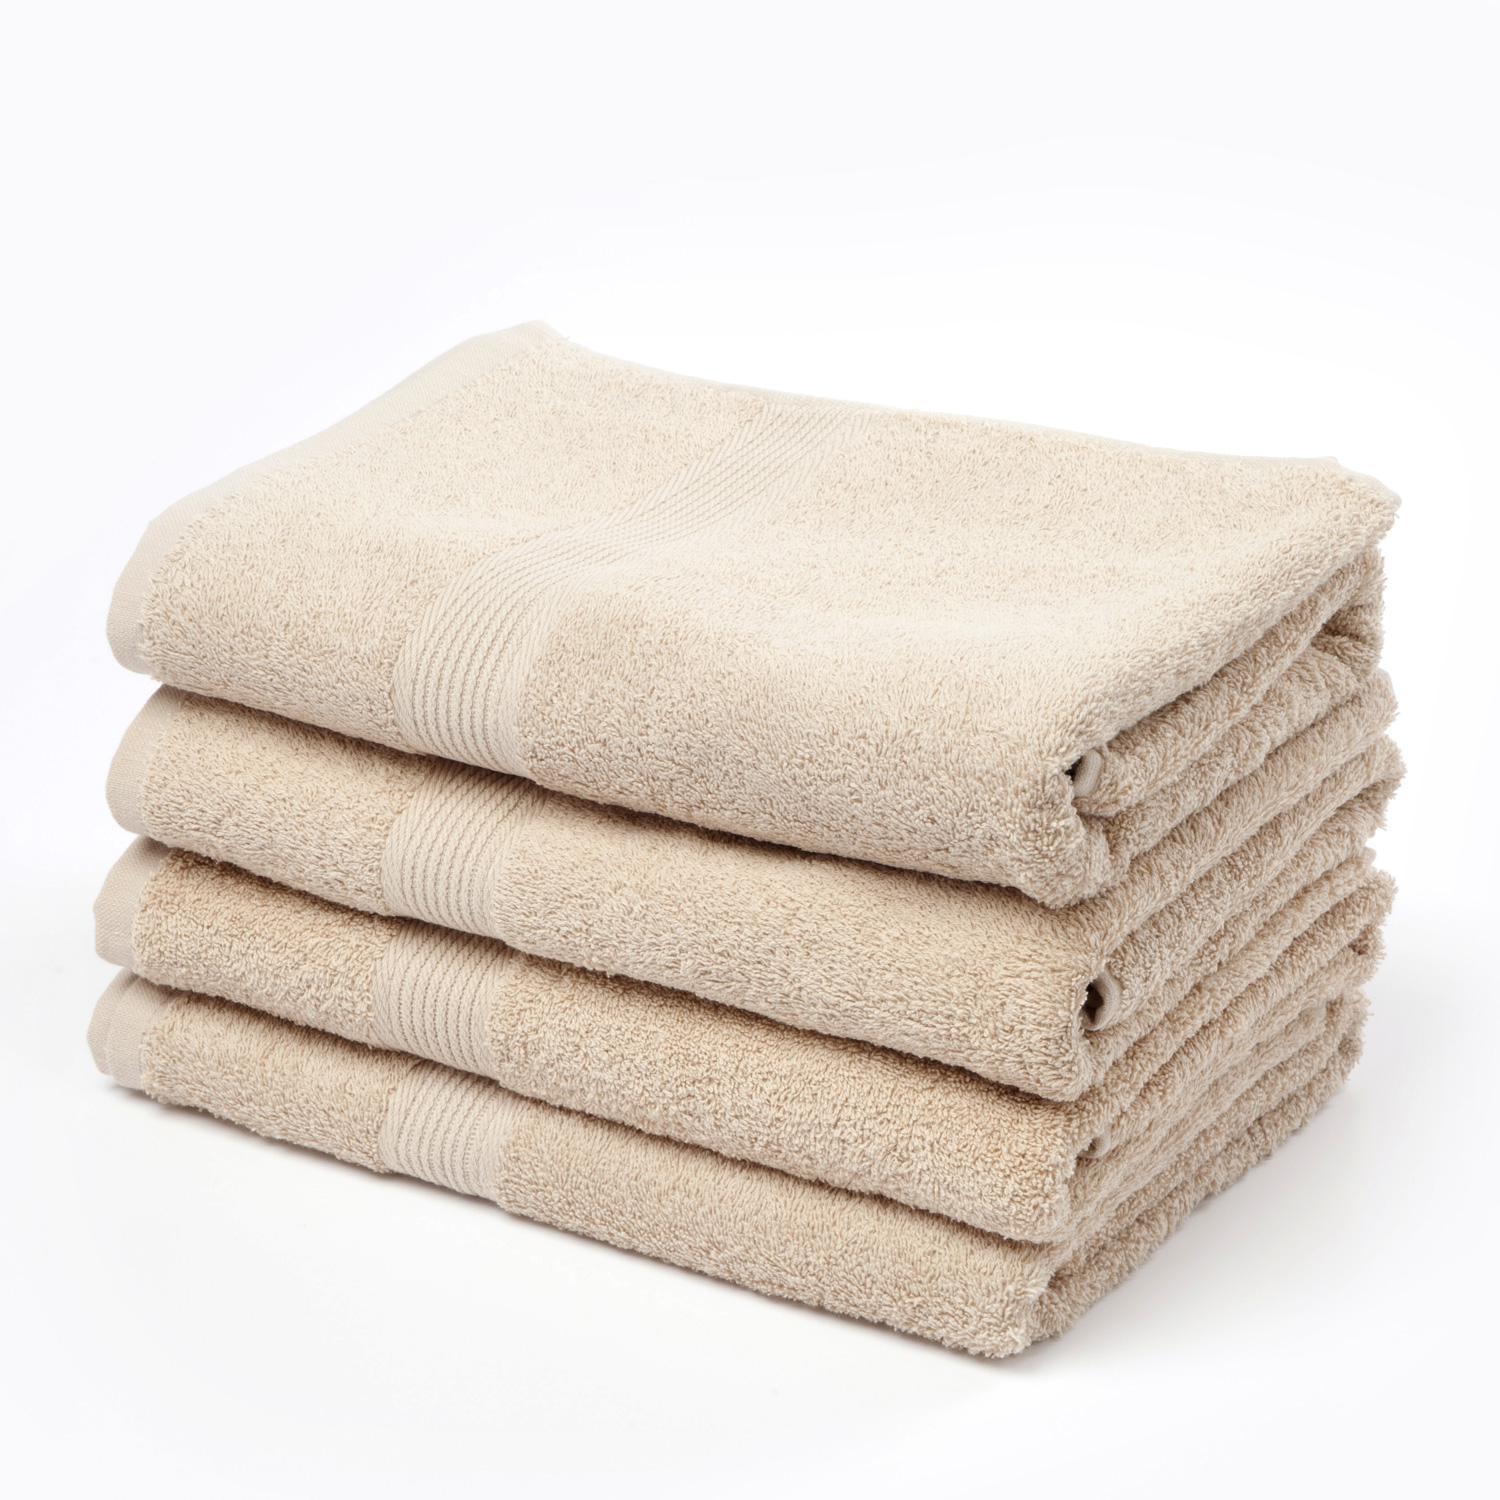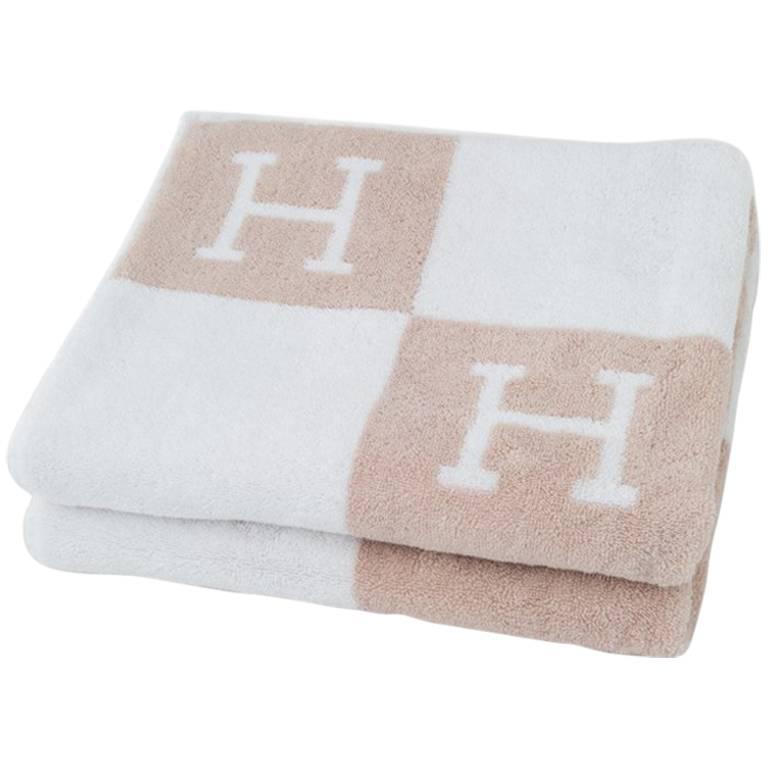The first image is the image on the left, the second image is the image on the right. For the images displayed, is the sentence "There is no less than six towels." factually correct? Answer yes or no. Yes. The first image is the image on the left, the second image is the image on the right. Evaluate the accuracy of this statement regarding the images: "There are exactly two towels.". Is it true? Answer yes or no. No. 